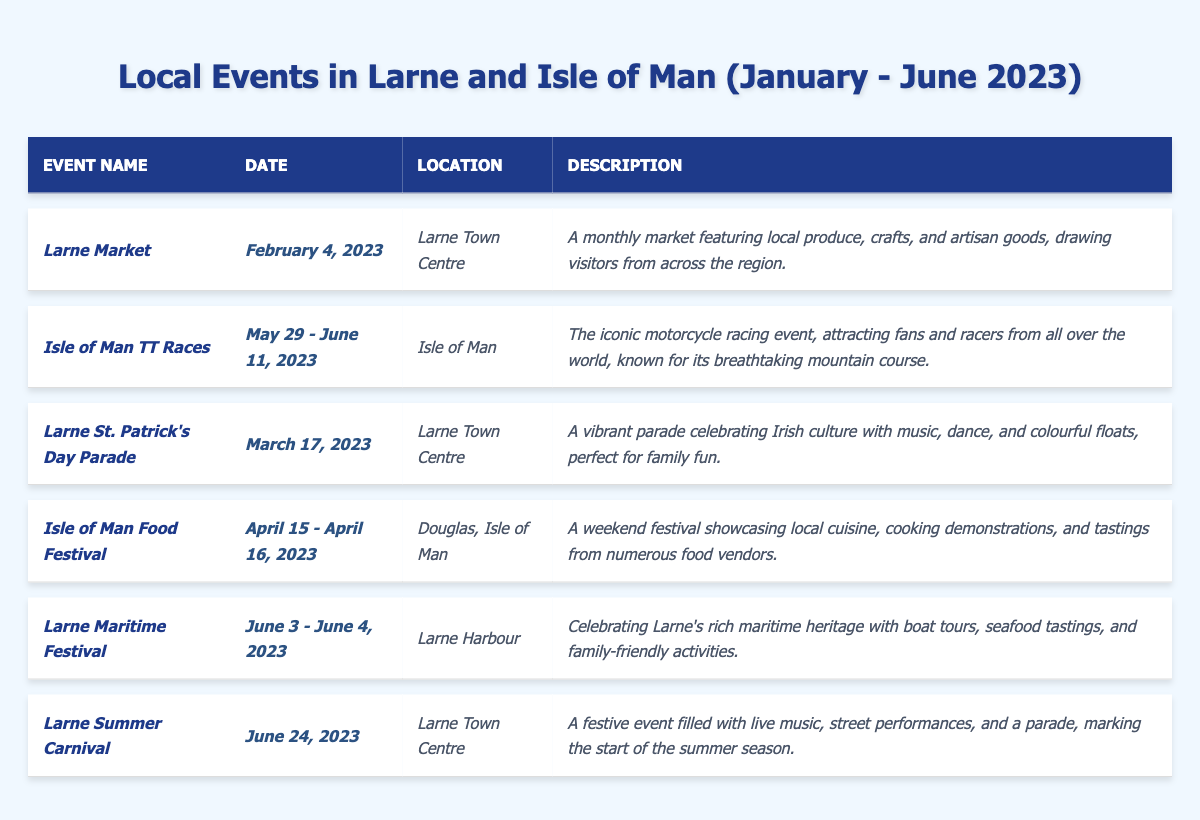What event takes place on March 17, 2023? The table shows that the "Larne St. Patrick's Day Parade" occurs on this date.
Answer: Larne St. Patrick's Day Parade Where is the Isle of Man Food Festival held? The location listed in the table for the Isle of Man Food Festival is "Douglas, Isle of Man."
Answer: Douglas, Isle of Man How many events are happening in Larne Town Centre? The events listed in the table that take place in Larne Town Centre are the Larne Market, Larne St. Patrick's Day Parade, and Larne Summer Carnival, making a total of 3 events.
Answer: 3 Is the Larne Maritime Festival a two-day event? The table notes that the Larne Maritime Festival takes place over two days, from June 3 to June 4, 2023.
Answer: Yes What is the date range for the Isle of Man TT Races? According to the table, the Isle of Man TT Races occur from May 29 to June 11, 2023.
Answer: May 29 - June 11, 2023 Which event features local cuisine and cooking demonstrations? The Isle of Man Food Festival is described in the table as featuring local cuisine and cooking demonstrations.
Answer: Isle of Man Food Festival Are there more events scheduled for Larne than for the Isle of Man? The table shows a total of 4 events in Larne (Market, St. Patrick's Day Parade, Maritime Festival, and Summer Carnival) and 2 events in the Isle of Man (TT Races, Food Festival), so there are more events in Larne.
Answer: Yes Which event has a maritime theme? The "Larne Maritime Festival" is indicated in the table as celebrating Larne's maritime heritage.
Answer: Larne Maritime Festival What type of activities can one expect at the Larne Summer Carnival? The Larne Summer Carnival includes live music, street performances, and a parade as per the description in the table.
Answer: Live music, street performances, and parade What is the duration of the Isle of Man Food Festival? The table specifies that the Isle of Man Food Festival lasts for two days, from April 15 to April 16, 2023.
Answer: 2 days Which event is described as a vibrant celebration of Irish culture? The event described in the table as celebrating Irish culture is the "Larne St. Patrick's Day Parade."
Answer: Larne St. Patrick's Day Parade 